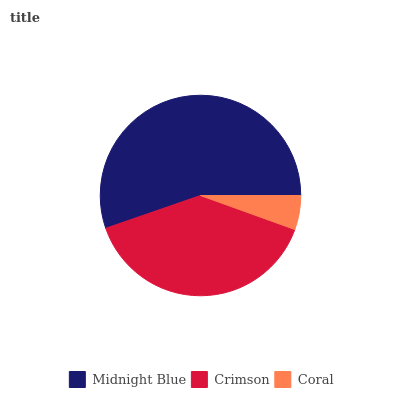Is Coral the minimum?
Answer yes or no. Yes. Is Midnight Blue the maximum?
Answer yes or no. Yes. Is Crimson the minimum?
Answer yes or no. No. Is Crimson the maximum?
Answer yes or no. No. Is Midnight Blue greater than Crimson?
Answer yes or no. Yes. Is Crimson less than Midnight Blue?
Answer yes or no. Yes. Is Crimson greater than Midnight Blue?
Answer yes or no. No. Is Midnight Blue less than Crimson?
Answer yes or no. No. Is Crimson the high median?
Answer yes or no. Yes. Is Crimson the low median?
Answer yes or no. Yes. Is Coral the high median?
Answer yes or no. No. Is Coral the low median?
Answer yes or no. No. 